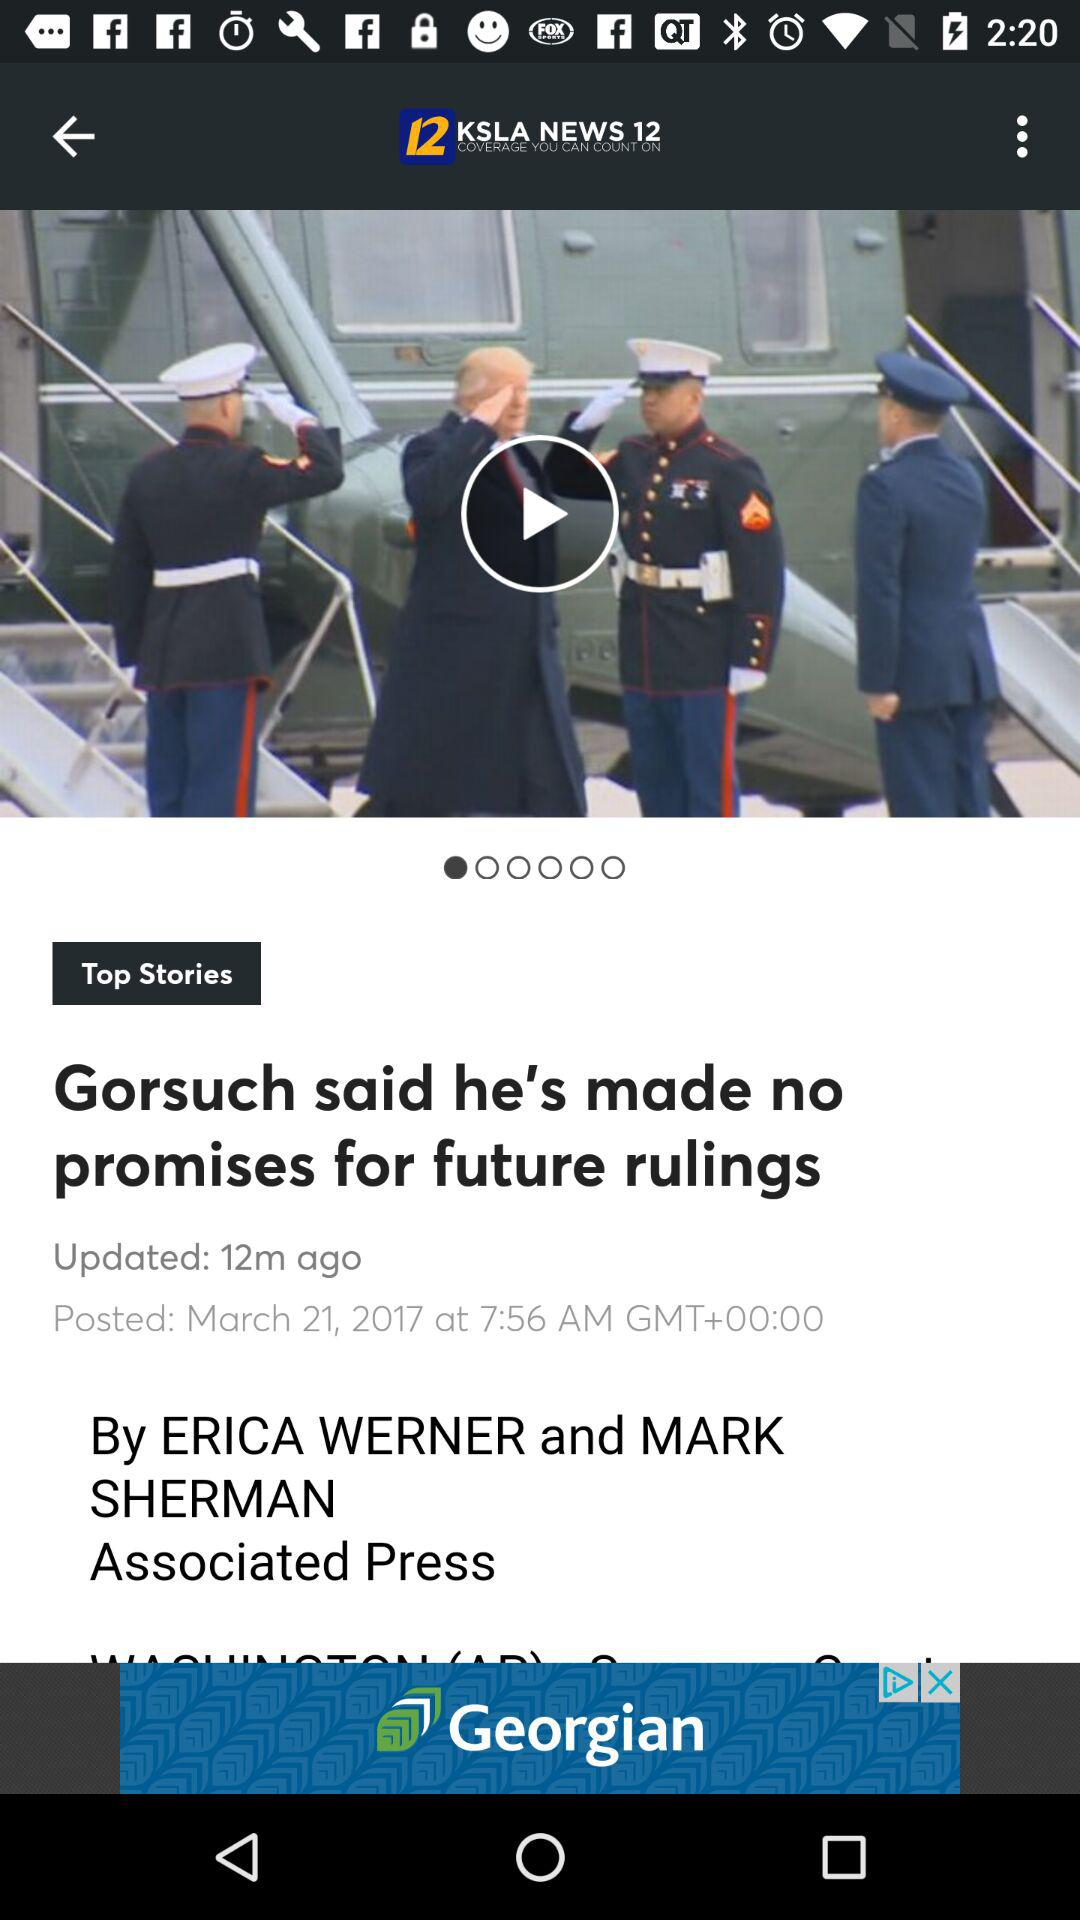Who posted the article? The article was posted by ERICA WERNER and MARK SHERMAN. 